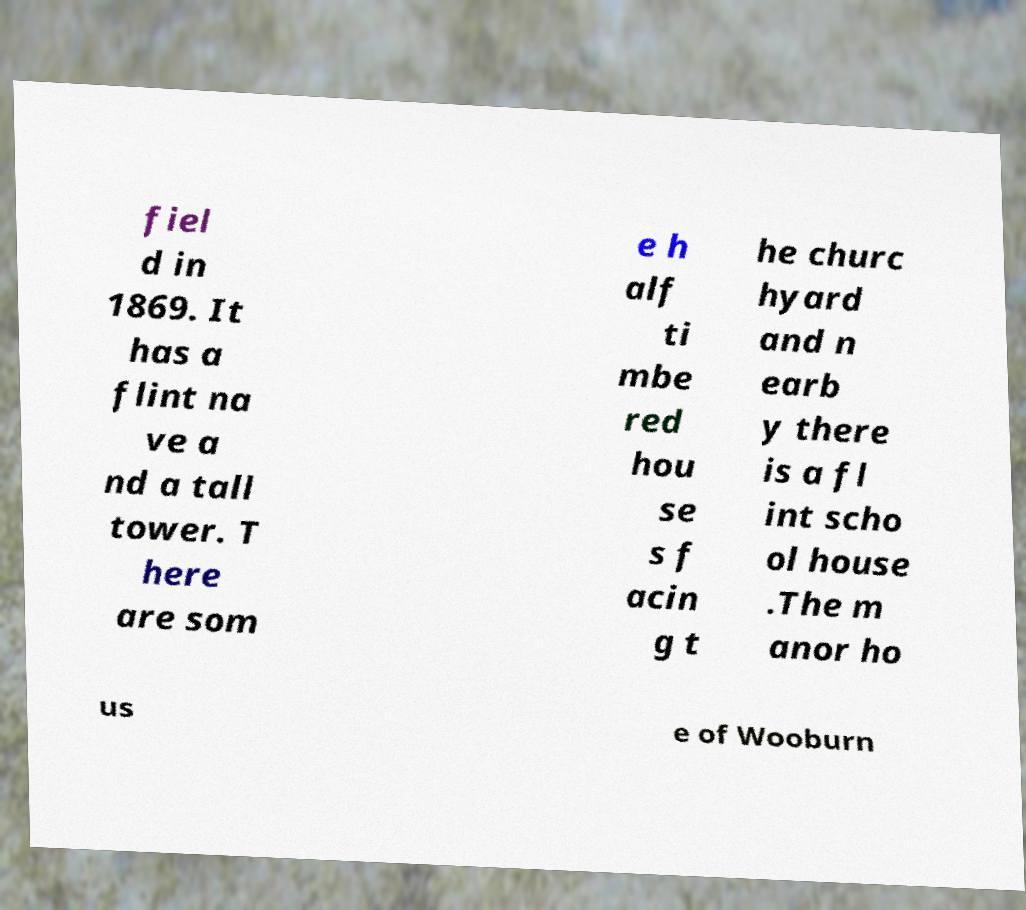There's text embedded in this image that I need extracted. Can you transcribe it verbatim? fiel d in 1869. It has a flint na ve a nd a tall tower. T here are som e h alf ti mbe red hou se s f acin g t he churc hyard and n earb y there is a fl int scho ol house .The m anor ho us e of Wooburn 